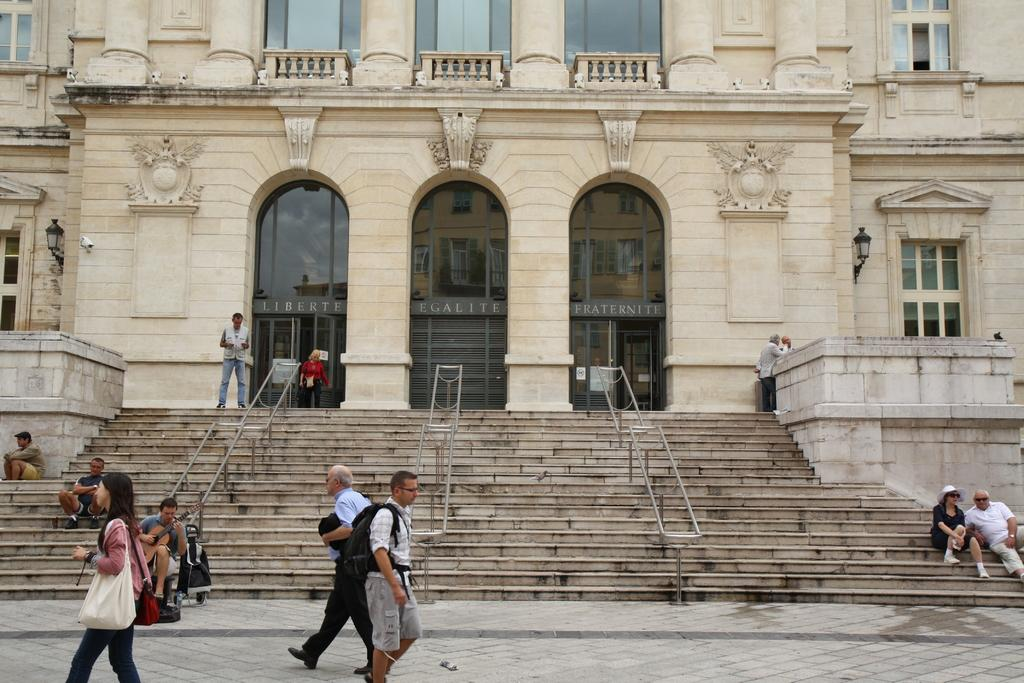What features can be observed on the building in the image? The building has windows, doors, and lights. What architectural element is present in front of the building? There are steps in front of the building. Are there any people present in the image? Yes, there are people in front of the building. What activity is one of the people engaged in? One person is playing a guitar. What type of paper is being used to create the skin of the building in the image? There is no paper or skin mentioned in the image; the building is made of traditional construction materials. 